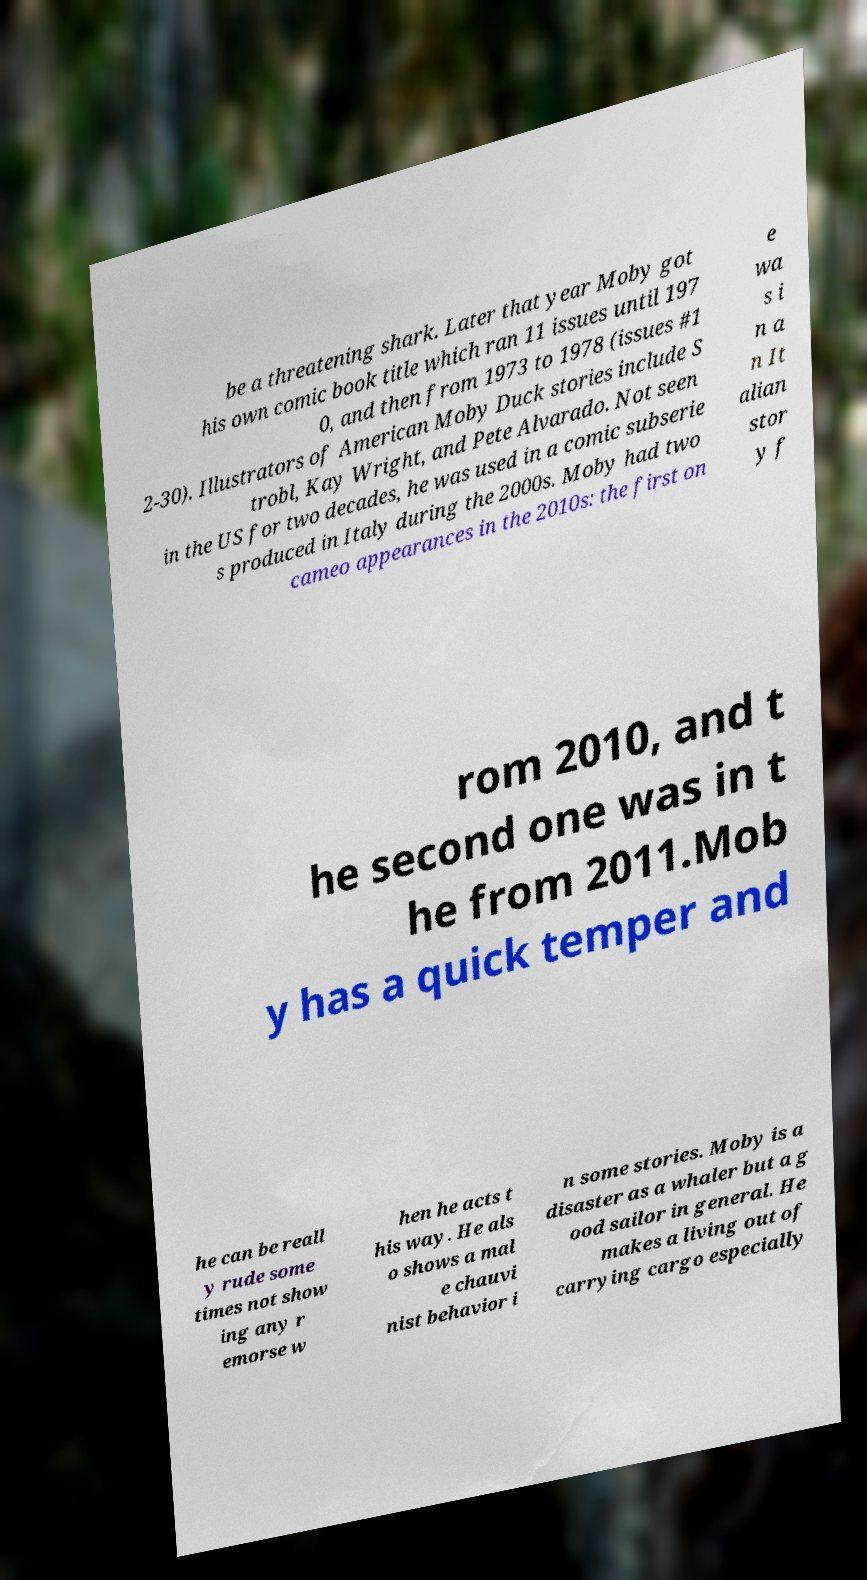I need the written content from this picture converted into text. Can you do that? be a threatening shark. Later that year Moby got his own comic book title which ran 11 issues until 197 0, and then from 1973 to 1978 (issues #1 2-30). Illustrators of American Moby Duck stories include S trobl, Kay Wright, and Pete Alvarado. Not seen in the US for two decades, he was used in a comic subserie s produced in Italy during the 2000s. Moby had two cameo appearances in the 2010s: the first on e wa s i n a n It alian stor y f rom 2010, and t he second one was in t he from 2011.Mob y has a quick temper and he can be reall y rude some times not show ing any r emorse w hen he acts t his way. He als o shows a mal e chauvi nist behavior i n some stories. Moby is a disaster as a whaler but a g ood sailor in general. He makes a living out of carrying cargo especially 